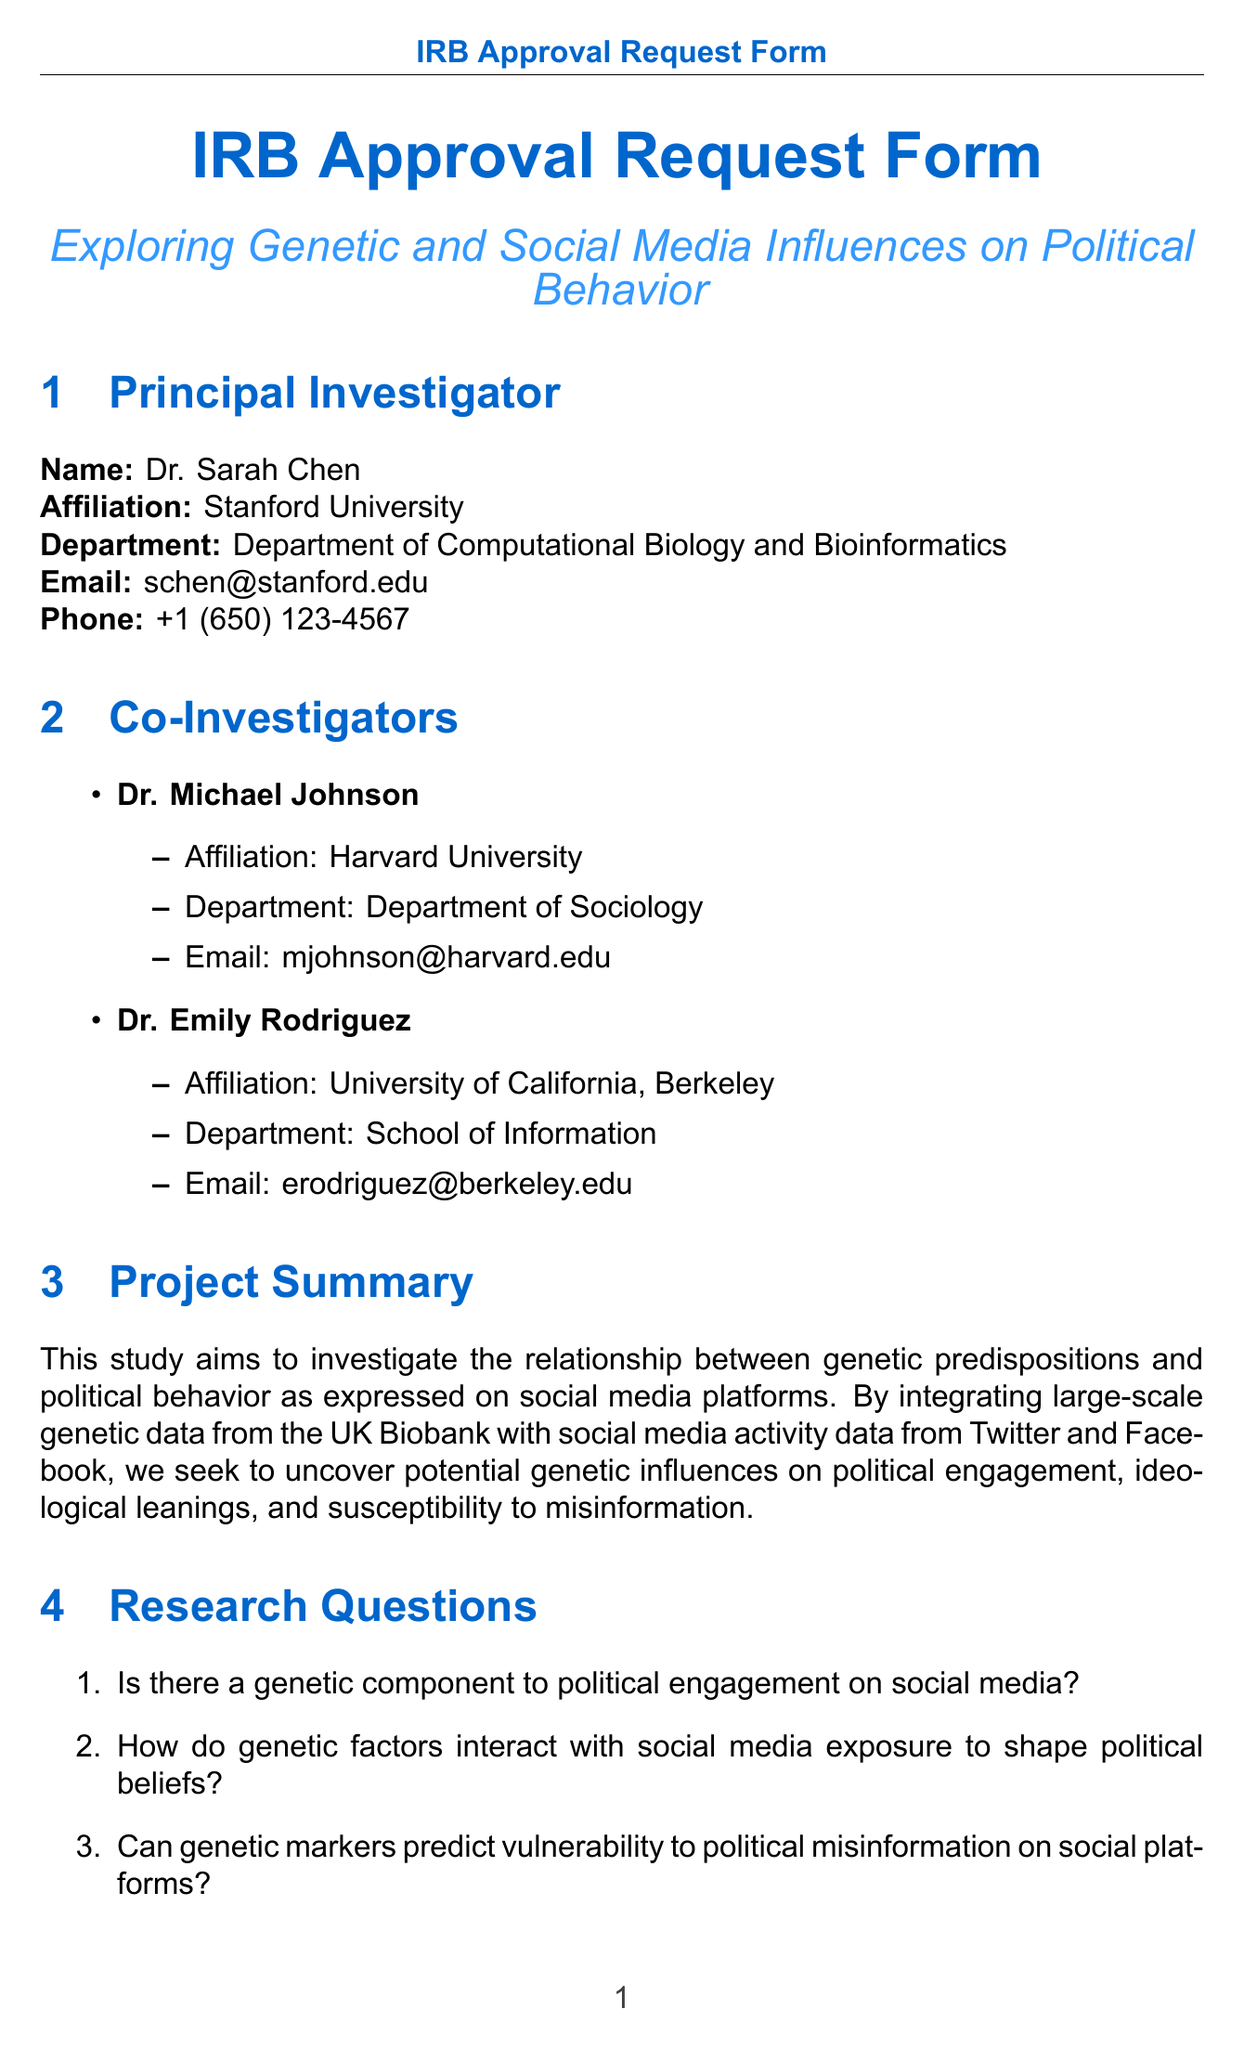What is the project title? The project title is listed in the document section, which is clearly stated as "Exploring Genetic and Social Media Influences on Political Behavior."
Answer: Exploring Genetic and Social Media Influences on Political Behavior Who is the principal investigator? The principal investigator is named at the beginning of the document, which identifies Dr. Sarah Chen as the principal investigator.
Answer: Dr. Sarah Chen What is the sample size of the UK Biobank data? The sample size for the UK Biobank is specified in the data sources section as 500,000.
Answer: 500000 What are the ethical considerations listed? The document outlines several ethical considerations that are highlighted in the relevant section of the form.
Answer: Privacy protection for genetic and social media data, Potential for stigmatization based on genetic findings, Implications for free will and determinism in political behavior, Risks of data breach or misuse What is the funding source for the project? The funding source is explicitly identified under the funding source section of the document as the National Science Foundation.
Answer: National Science Foundation How long will the data be retained post-study? The retention period for data is mentioned in the data management plan section, which states the duration clearly.
Answer: 5 years post-study What two-step consent process will be implemented for social media data? The informed consent process describes the steps taken regarding data collection, elaborating on the automated notification and opt-out options.
Answer: Automated notification to users about data collection and option to opt-out or provide explicit consent What is the total budget for the project? The amount for the project's funding is provided in the funding source section, clearly stating the total budget amount.
Answer: $2,500,000 When is the final report expected to be submitted? The timeline section includes specific dates for milestones, including the submission of the final report.
Answer: 2026-06-30 